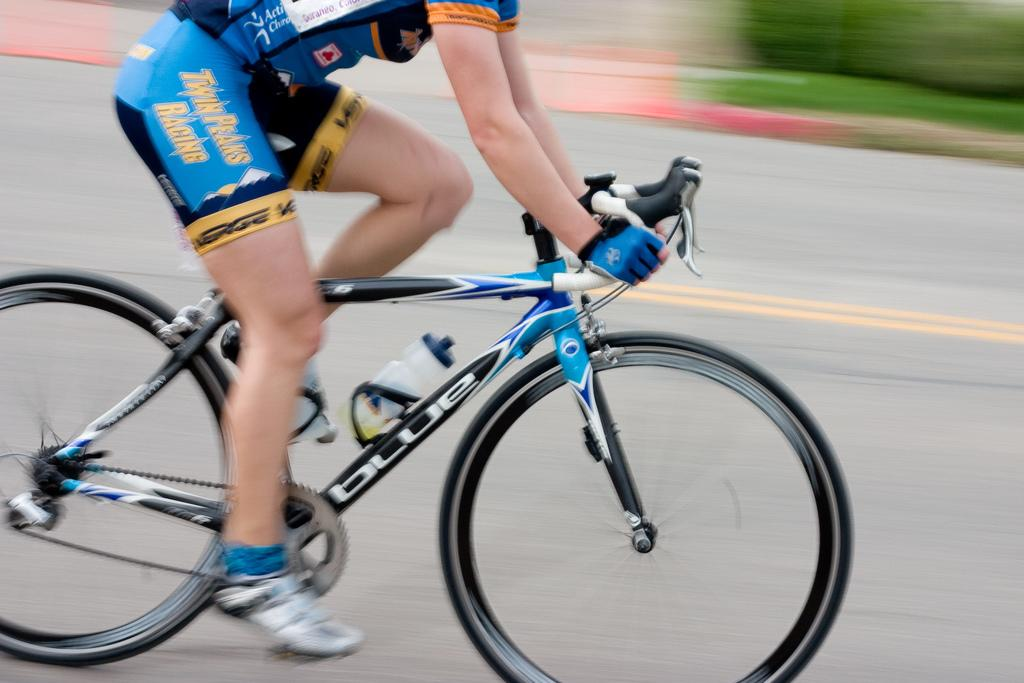What is the person in the image doing? The person is riding a bicycle in the image. Where is the person riding the bicycle? The person is on the road. What else can be seen in the image besides the person on the bicycle? There are plants visible in the image. What type of song can be heard playing in the background of the image? There is no song or audio present in the image, as it is a still photograph. 